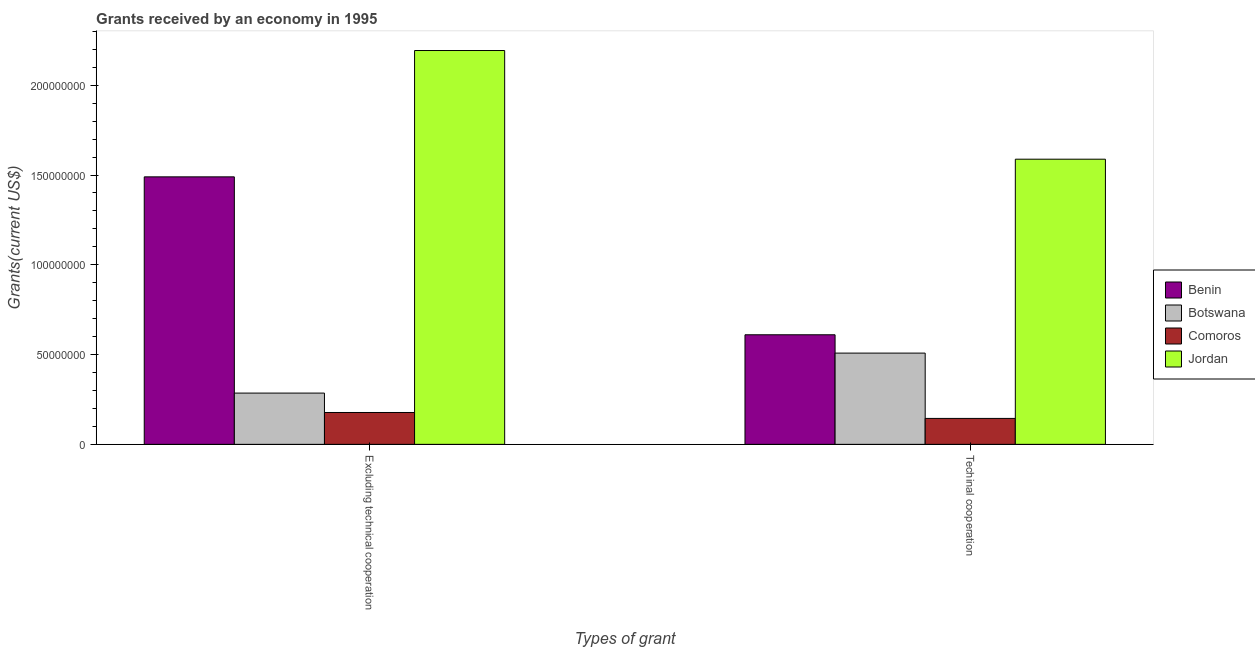Are the number of bars on each tick of the X-axis equal?
Your response must be concise. Yes. How many bars are there on the 2nd tick from the left?
Offer a very short reply. 4. What is the label of the 1st group of bars from the left?
Provide a succinct answer. Excluding technical cooperation. What is the amount of grants received(excluding technical cooperation) in Botswana?
Provide a short and direct response. 2.86e+07. Across all countries, what is the maximum amount of grants received(excluding technical cooperation)?
Provide a succinct answer. 2.19e+08. Across all countries, what is the minimum amount of grants received(including technical cooperation)?
Your answer should be compact. 1.44e+07. In which country was the amount of grants received(excluding technical cooperation) maximum?
Keep it short and to the point. Jordan. In which country was the amount of grants received(excluding technical cooperation) minimum?
Provide a succinct answer. Comoros. What is the total amount of grants received(excluding technical cooperation) in the graph?
Offer a very short reply. 4.15e+08. What is the difference between the amount of grants received(excluding technical cooperation) in Botswana and that in Benin?
Your response must be concise. -1.20e+08. What is the difference between the amount of grants received(including technical cooperation) in Comoros and the amount of grants received(excluding technical cooperation) in Botswana?
Keep it short and to the point. -1.41e+07. What is the average amount of grants received(including technical cooperation) per country?
Your response must be concise. 7.13e+07. What is the difference between the amount of grants received(including technical cooperation) and amount of grants received(excluding technical cooperation) in Jordan?
Your answer should be very brief. -6.05e+07. What is the ratio of the amount of grants received(including technical cooperation) in Benin to that in Comoros?
Give a very brief answer. 4.22. Is the amount of grants received(excluding technical cooperation) in Comoros less than that in Botswana?
Provide a short and direct response. Yes. In how many countries, is the amount of grants received(excluding technical cooperation) greater than the average amount of grants received(excluding technical cooperation) taken over all countries?
Give a very brief answer. 2. What does the 4th bar from the left in Excluding technical cooperation represents?
Provide a short and direct response. Jordan. What does the 3rd bar from the right in Excluding technical cooperation represents?
Your answer should be compact. Botswana. How many bars are there?
Provide a succinct answer. 8. How many countries are there in the graph?
Your response must be concise. 4. What is the difference between two consecutive major ticks on the Y-axis?
Your answer should be very brief. 5.00e+07. Are the values on the major ticks of Y-axis written in scientific E-notation?
Keep it short and to the point. No. How many legend labels are there?
Provide a succinct answer. 4. What is the title of the graph?
Keep it short and to the point. Grants received by an economy in 1995. What is the label or title of the X-axis?
Offer a terse response. Types of grant. What is the label or title of the Y-axis?
Keep it short and to the point. Grants(current US$). What is the Grants(current US$) in Benin in Excluding technical cooperation?
Keep it short and to the point. 1.49e+08. What is the Grants(current US$) of Botswana in Excluding technical cooperation?
Provide a short and direct response. 2.86e+07. What is the Grants(current US$) of Comoros in Excluding technical cooperation?
Your answer should be compact. 1.78e+07. What is the Grants(current US$) of Jordan in Excluding technical cooperation?
Give a very brief answer. 2.19e+08. What is the Grants(current US$) in Benin in Techinal cooperation?
Provide a succinct answer. 6.10e+07. What is the Grants(current US$) in Botswana in Techinal cooperation?
Your response must be concise. 5.08e+07. What is the Grants(current US$) of Comoros in Techinal cooperation?
Your answer should be very brief. 1.44e+07. What is the Grants(current US$) of Jordan in Techinal cooperation?
Provide a succinct answer. 1.59e+08. Across all Types of grant, what is the maximum Grants(current US$) in Benin?
Your response must be concise. 1.49e+08. Across all Types of grant, what is the maximum Grants(current US$) in Botswana?
Offer a terse response. 5.08e+07. Across all Types of grant, what is the maximum Grants(current US$) of Comoros?
Provide a short and direct response. 1.78e+07. Across all Types of grant, what is the maximum Grants(current US$) in Jordan?
Give a very brief answer. 2.19e+08. Across all Types of grant, what is the minimum Grants(current US$) in Benin?
Offer a very short reply. 6.10e+07. Across all Types of grant, what is the minimum Grants(current US$) in Botswana?
Your answer should be very brief. 2.86e+07. Across all Types of grant, what is the minimum Grants(current US$) in Comoros?
Provide a succinct answer. 1.44e+07. Across all Types of grant, what is the minimum Grants(current US$) of Jordan?
Make the answer very short. 1.59e+08. What is the total Grants(current US$) in Benin in the graph?
Offer a very short reply. 2.10e+08. What is the total Grants(current US$) of Botswana in the graph?
Provide a succinct answer. 7.94e+07. What is the total Grants(current US$) of Comoros in the graph?
Make the answer very short. 3.22e+07. What is the total Grants(current US$) in Jordan in the graph?
Make the answer very short. 3.78e+08. What is the difference between the Grants(current US$) in Benin in Excluding technical cooperation and that in Techinal cooperation?
Your answer should be very brief. 8.79e+07. What is the difference between the Grants(current US$) of Botswana in Excluding technical cooperation and that in Techinal cooperation?
Provide a succinct answer. -2.23e+07. What is the difference between the Grants(current US$) of Comoros in Excluding technical cooperation and that in Techinal cooperation?
Your answer should be very brief. 3.30e+06. What is the difference between the Grants(current US$) in Jordan in Excluding technical cooperation and that in Techinal cooperation?
Provide a short and direct response. 6.05e+07. What is the difference between the Grants(current US$) of Benin in Excluding technical cooperation and the Grants(current US$) of Botswana in Techinal cooperation?
Your answer should be very brief. 9.82e+07. What is the difference between the Grants(current US$) of Benin in Excluding technical cooperation and the Grants(current US$) of Comoros in Techinal cooperation?
Your response must be concise. 1.35e+08. What is the difference between the Grants(current US$) in Benin in Excluding technical cooperation and the Grants(current US$) in Jordan in Techinal cooperation?
Give a very brief answer. -9.84e+06. What is the difference between the Grants(current US$) in Botswana in Excluding technical cooperation and the Grants(current US$) in Comoros in Techinal cooperation?
Give a very brief answer. 1.41e+07. What is the difference between the Grants(current US$) in Botswana in Excluding technical cooperation and the Grants(current US$) in Jordan in Techinal cooperation?
Make the answer very short. -1.30e+08. What is the difference between the Grants(current US$) of Comoros in Excluding technical cooperation and the Grants(current US$) of Jordan in Techinal cooperation?
Ensure brevity in your answer.  -1.41e+08. What is the average Grants(current US$) of Benin per Types of grant?
Ensure brevity in your answer.  1.05e+08. What is the average Grants(current US$) in Botswana per Types of grant?
Ensure brevity in your answer.  3.97e+07. What is the average Grants(current US$) in Comoros per Types of grant?
Offer a very short reply. 1.61e+07. What is the average Grants(current US$) in Jordan per Types of grant?
Make the answer very short. 1.89e+08. What is the difference between the Grants(current US$) in Benin and Grants(current US$) in Botswana in Excluding technical cooperation?
Your answer should be compact. 1.20e+08. What is the difference between the Grants(current US$) in Benin and Grants(current US$) in Comoros in Excluding technical cooperation?
Provide a short and direct response. 1.31e+08. What is the difference between the Grants(current US$) of Benin and Grants(current US$) of Jordan in Excluding technical cooperation?
Ensure brevity in your answer.  -7.04e+07. What is the difference between the Grants(current US$) in Botswana and Grants(current US$) in Comoros in Excluding technical cooperation?
Keep it short and to the point. 1.08e+07. What is the difference between the Grants(current US$) of Botswana and Grants(current US$) of Jordan in Excluding technical cooperation?
Ensure brevity in your answer.  -1.91e+08. What is the difference between the Grants(current US$) of Comoros and Grants(current US$) of Jordan in Excluding technical cooperation?
Make the answer very short. -2.02e+08. What is the difference between the Grants(current US$) of Benin and Grants(current US$) of Botswana in Techinal cooperation?
Your response must be concise. 1.02e+07. What is the difference between the Grants(current US$) in Benin and Grants(current US$) in Comoros in Techinal cooperation?
Provide a succinct answer. 4.66e+07. What is the difference between the Grants(current US$) in Benin and Grants(current US$) in Jordan in Techinal cooperation?
Your response must be concise. -9.78e+07. What is the difference between the Grants(current US$) in Botswana and Grants(current US$) in Comoros in Techinal cooperation?
Provide a short and direct response. 3.64e+07. What is the difference between the Grants(current US$) of Botswana and Grants(current US$) of Jordan in Techinal cooperation?
Offer a terse response. -1.08e+08. What is the difference between the Grants(current US$) of Comoros and Grants(current US$) of Jordan in Techinal cooperation?
Ensure brevity in your answer.  -1.44e+08. What is the ratio of the Grants(current US$) of Benin in Excluding technical cooperation to that in Techinal cooperation?
Your response must be concise. 2.44. What is the ratio of the Grants(current US$) in Botswana in Excluding technical cooperation to that in Techinal cooperation?
Give a very brief answer. 0.56. What is the ratio of the Grants(current US$) of Comoros in Excluding technical cooperation to that in Techinal cooperation?
Keep it short and to the point. 1.23. What is the ratio of the Grants(current US$) in Jordan in Excluding technical cooperation to that in Techinal cooperation?
Provide a succinct answer. 1.38. What is the difference between the highest and the second highest Grants(current US$) in Benin?
Provide a succinct answer. 8.79e+07. What is the difference between the highest and the second highest Grants(current US$) in Botswana?
Keep it short and to the point. 2.23e+07. What is the difference between the highest and the second highest Grants(current US$) in Comoros?
Your response must be concise. 3.30e+06. What is the difference between the highest and the second highest Grants(current US$) of Jordan?
Keep it short and to the point. 6.05e+07. What is the difference between the highest and the lowest Grants(current US$) of Benin?
Provide a short and direct response. 8.79e+07. What is the difference between the highest and the lowest Grants(current US$) in Botswana?
Provide a succinct answer. 2.23e+07. What is the difference between the highest and the lowest Grants(current US$) of Comoros?
Offer a terse response. 3.30e+06. What is the difference between the highest and the lowest Grants(current US$) of Jordan?
Provide a short and direct response. 6.05e+07. 